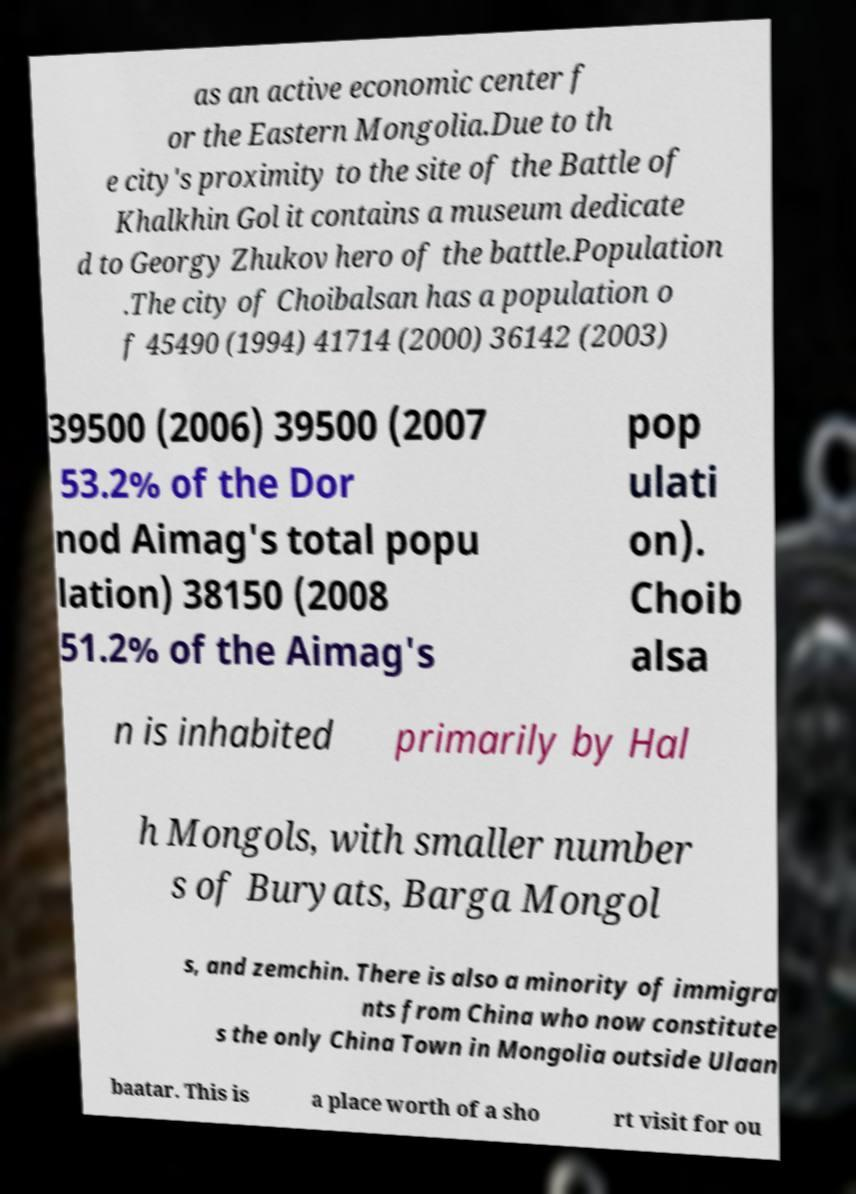There's text embedded in this image that I need extracted. Can you transcribe it verbatim? as an active economic center f or the Eastern Mongolia.Due to th e city's proximity to the site of the Battle of Khalkhin Gol it contains a museum dedicate d to Georgy Zhukov hero of the battle.Population .The city of Choibalsan has a population o f 45490 (1994) 41714 (2000) 36142 (2003) 39500 (2006) 39500 (2007 53.2% of the Dor nod Aimag's total popu lation) 38150 (2008 51.2% of the Aimag's pop ulati on). Choib alsa n is inhabited primarily by Hal h Mongols, with smaller number s of Buryats, Barga Mongol s, and zemchin. There is also a minority of immigra nts from China who now constitute s the only China Town in Mongolia outside Ulaan baatar. This is a place worth of a sho rt visit for ou 